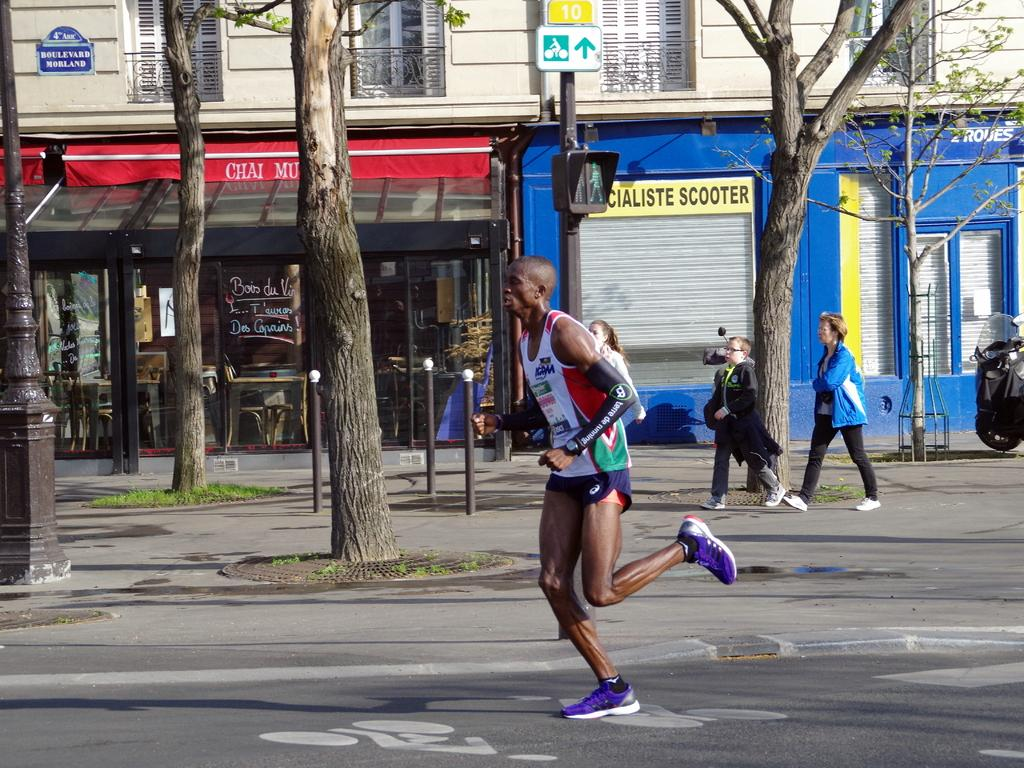How many people are in the image? There is a group of people in the image, but the exact number cannot be determined from the provided facts. What objects can be seen in the image besides the people? There are poles and trees present on the ground in the image. What can be seen in the background of the image? There is a building and windows visible in the background of the image. Which direction are the trains moving in the image? There are no trains present in the image, so it is not possible to determine their direction. 